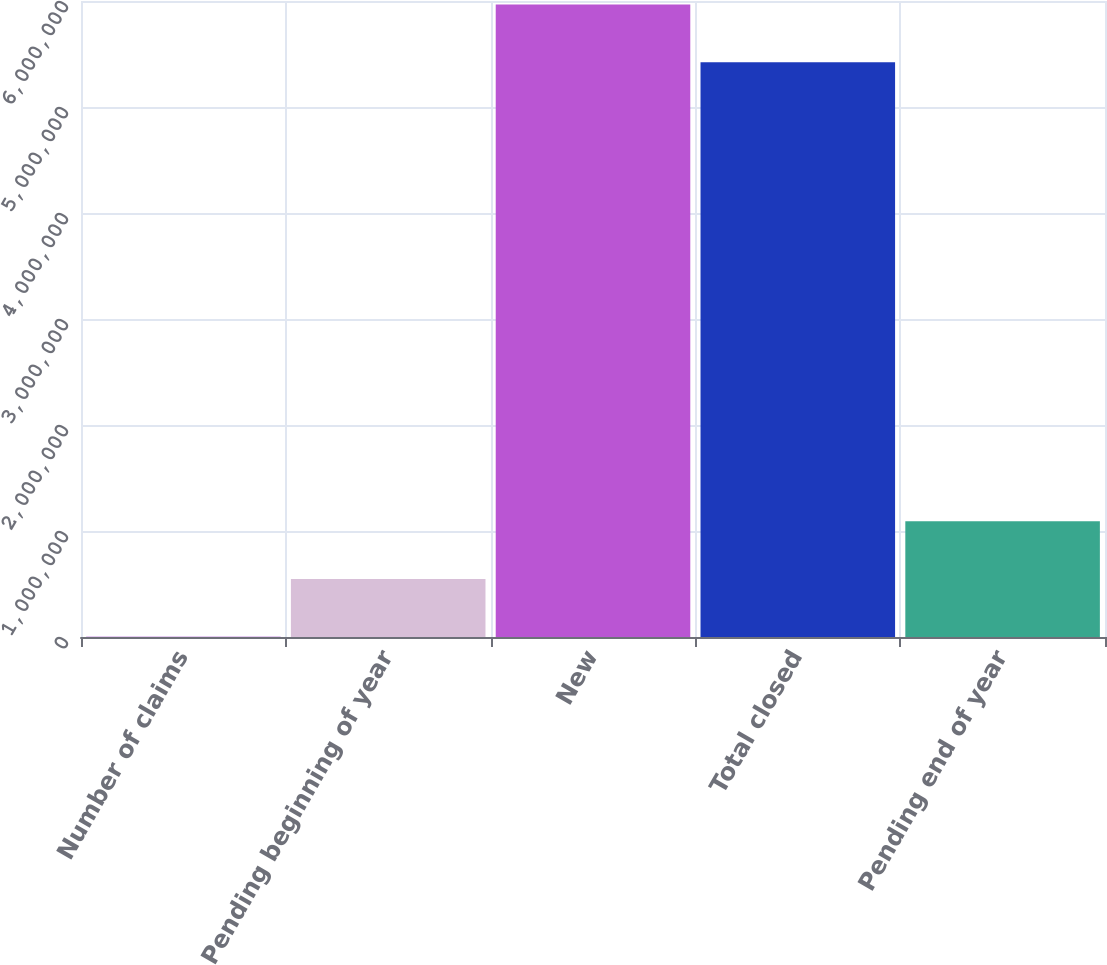Convert chart to OTSL. <chart><loc_0><loc_0><loc_500><loc_500><bar_chart><fcel>Number of claims<fcel>Pending beginning of year<fcel>New<fcel>Total closed<fcel>Pending end of year<nl><fcel>2007<fcel>546850<fcel>5.96623e+06<fcel>5.42138e+06<fcel>1.09169e+06<nl></chart> 